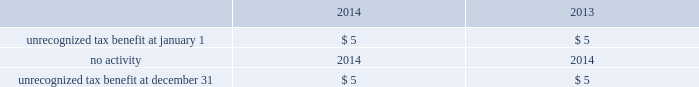Table of contents notes to consolidated financial statements of american airlines , inc .
American files its tax returns as prescribed by the tax laws of the jurisdictions in which it operates .
American 2019s 2004 through 2013 tax years are still subject to examination by the internal revenue service .
Various state and foreign jurisdiction tax years remain open to examination and american is under examination , in administrative appeals , or engaged in tax litigation in certain jurisdictions .
American believes that the effect of additional assessments will be immaterial to its consolidated financial statements .
American has an unrecognized tax benefit of approximately $ 5 million , which did not change during the twelve months ended december 31 , 2014 .
Changes in the unrecognized tax benefit have no impact on the effective tax rate due to the existence of the valuation allowance .
Accrued interest on tax positions is recorded as a component of interest expense but was not significant at december 31 , 2014 .
The reconciliation of the beginning and ending amounts of unrecognized tax benefit are ( in millions ) : .
American estimates that the unrecognized tax benefit will be realized within the next twelve months .
Risk management and financial instruments american 2019s economic prospects are heavily dependent upon two variables it cannot control : the health of the economy and the price of fuel .
Due to the discretionary nature of business and leisure travel spending , airline industry revenues are heavily influenced by the condition of the u.s .
Economy and economies in other regions of the world .
Unfavorable conditions in these broader economies have resulted , and may result in the future , in decreased passenger demand for air travel and changes in booking practices , both of which in turn have had , and may have in the future , a strong negative effect on american 2019s revenues .
In addition , during challenging economic times , actions by our competitors to increase their revenues can have an adverse impact on american 2019s revenues .
American 2019s operating results are materially impacted by changes in the availability , price volatility and cost of aircraft fuel , which represents one of the largest single cost items in american 2019s business .
Because of the amount of fuel needed to operate american 2019s business , even a relatively small increase in the price of fuel can have a material adverse aggregate effect on american 2019s operating results and liquidity .
Jet fuel market prices have fluctuated substantially over the past several years and prices continued to be volatile in 2014 .
These factors could impact american 2019s results of operations , financial performance and liquidity .
( a ) fuel price risk management during the second quarter of 2014 , american sold its portfolio of fuel hedging contracts that were scheduled to settle on or after june 30 , 2014 .
American has not entered into any transactions to hedge its fuel consumption since december 9 , 2013 and , accordingly , as of december 31 , 2014 , american did not have any fuel hedging contracts outstanding .
As such , and assuming american does not enter into any future transactions to hedge its fuel consumption , american will continue to be fully exposed to fluctuations in fuel prices .
American 2019s current policy is not to enter into transactions to hedge its fuel consumption , although american reviews that policy from time to time based on market conditions and other factors. .
What was the unrecognized tax benefit at december 31 , 2013? 
Computations: (5 * 1)
Answer: 5.0. 